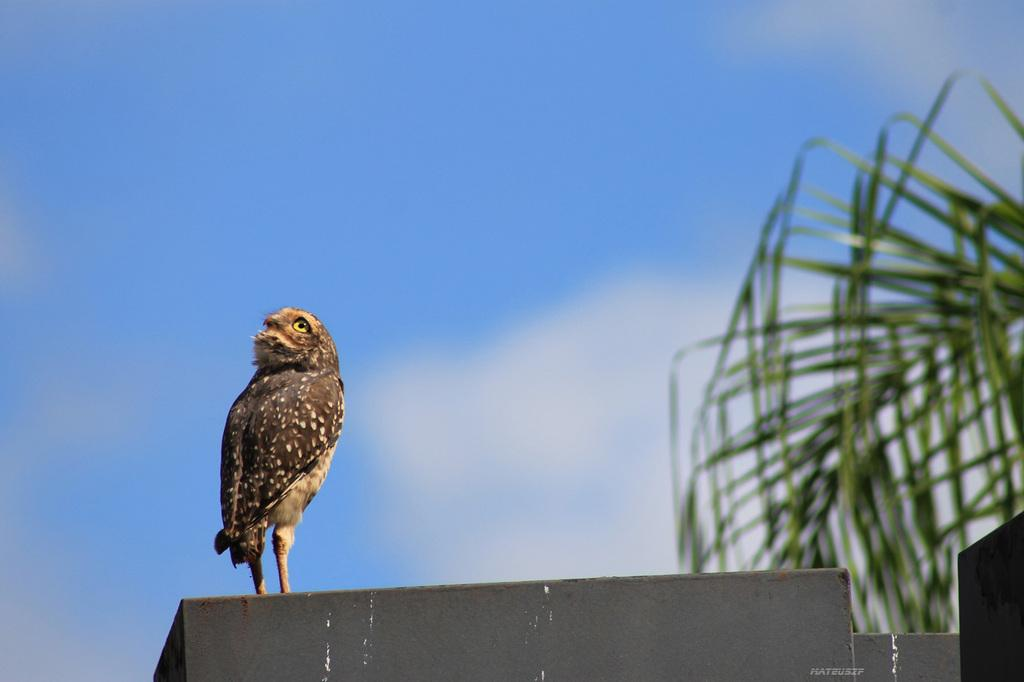What type of animal is on the surface in the image? There is a bird on the surface in the image. What can be seen on the right side of the image? There is a plant on the right side of the image. What is visible in the background of the image? The sky is visible in the background of the image, and it appears to be cloudy. What type of shoe is visible on the bird's foot in the image? There are no shoes present in the image; the bird is not wearing any footwear. 